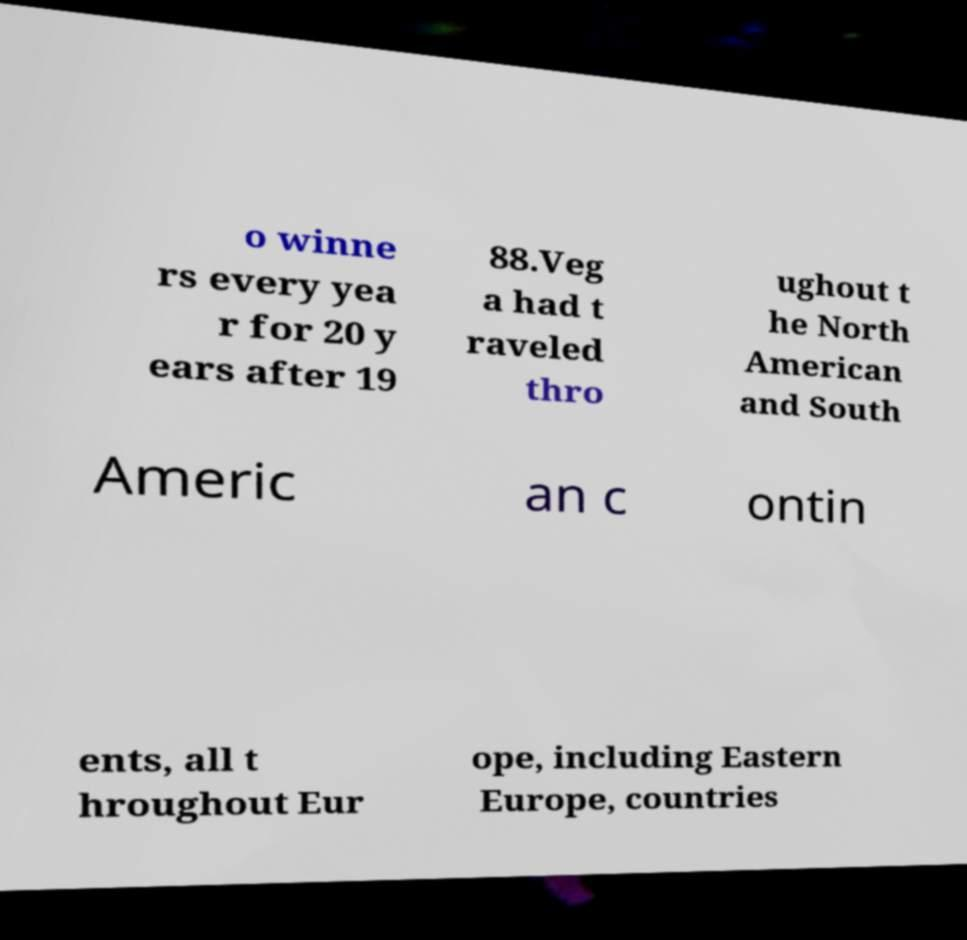I need the written content from this picture converted into text. Can you do that? o winne rs every yea r for 20 y ears after 19 88.Veg a had t raveled thro ughout t he North American and South Americ an c ontin ents, all t hroughout Eur ope, including Eastern Europe, countries 